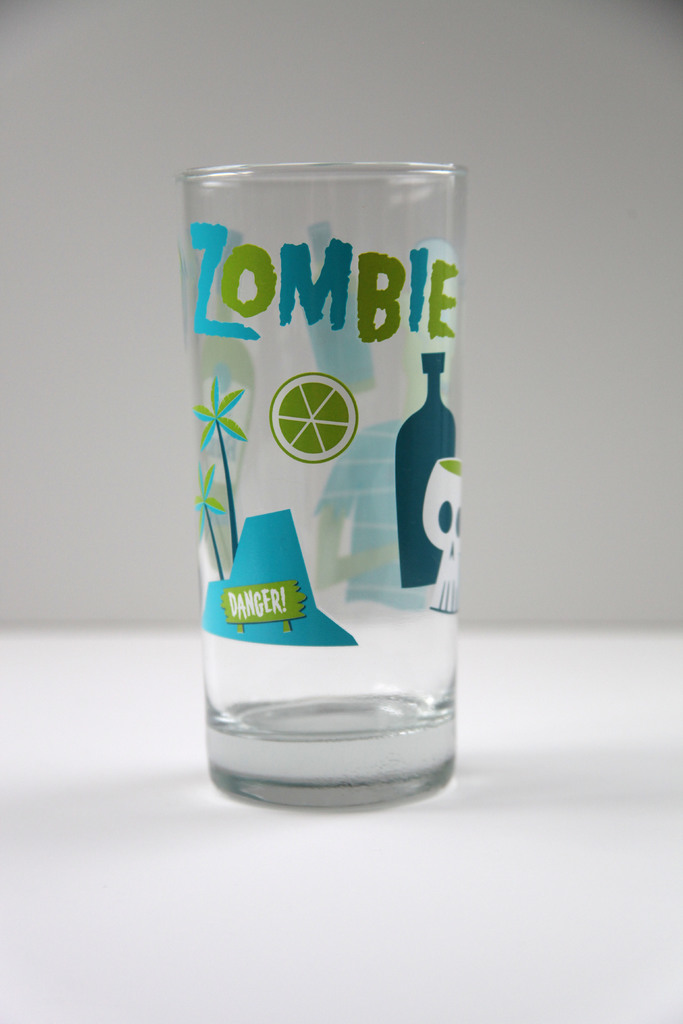Provide a one-sentence caption for the provided image.
Reference OCR token: ZOMBIE, DANGER! The clear glass features playful, vibrant graphics including the words 'ZOMBIE' in bold, lime-green letters, a stylized skull, and a tropical scene with palm trees, suggesting a fun, beach-themed cocktail glass. 